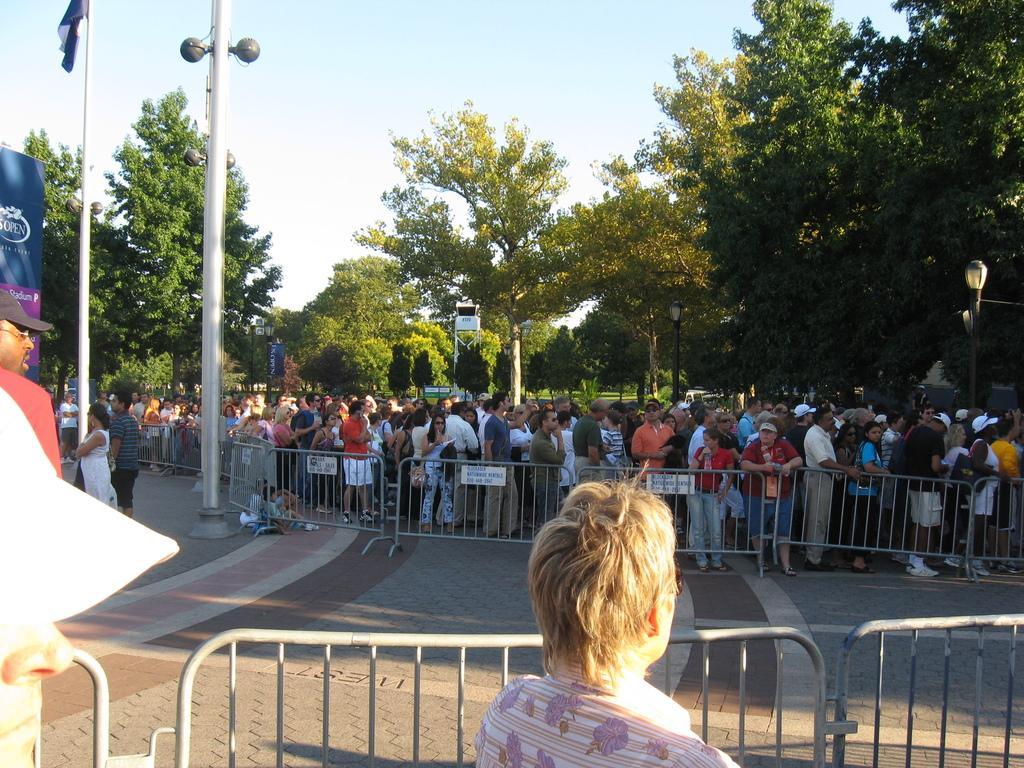Please provide a concise description of this image. In this image there are barriers , boards, group of people standing, there are poles, lights, a flag , there are trees, and in the background there is sky. 